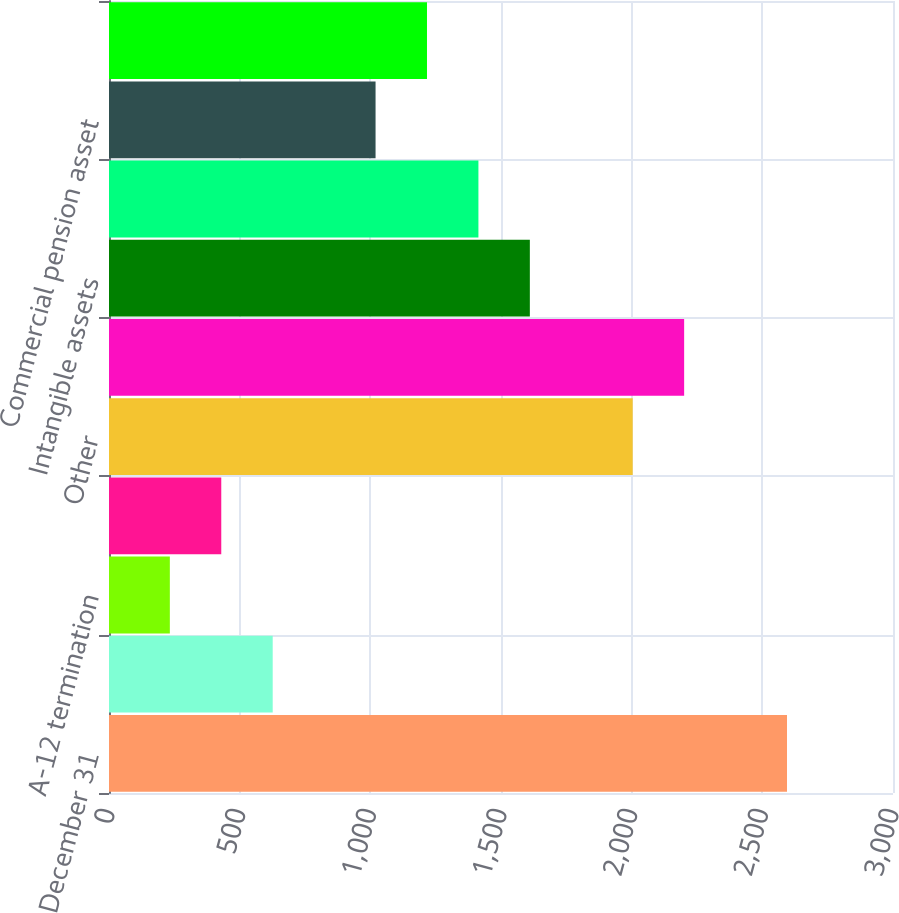Convert chart to OTSL. <chart><loc_0><loc_0><loc_500><loc_500><bar_chart><fcel>December 31<fcel>Post-retirement and<fcel>A-12 termination<fcel>Tax loss and credit<fcel>Other<fcel>Deferred assets<fcel>Intangible assets<fcel>Property basis differences<fcel>Commercial pension asset<fcel>Capital Construction Fund<nl><fcel>2594.4<fcel>626.4<fcel>232.8<fcel>429.6<fcel>2004<fcel>2200.8<fcel>1610.4<fcel>1413.6<fcel>1020<fcel>1216.8<nl></chart> 